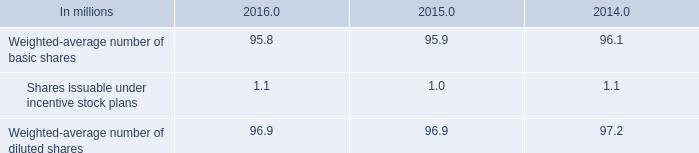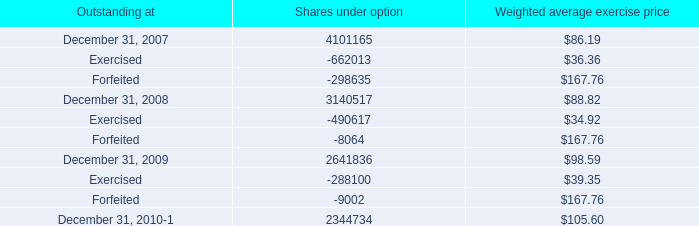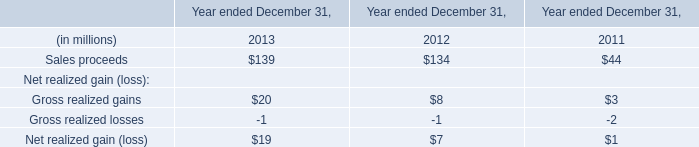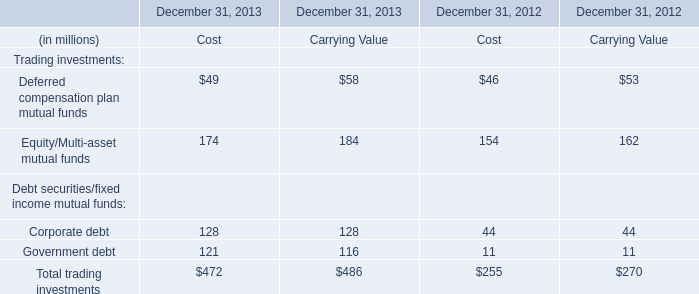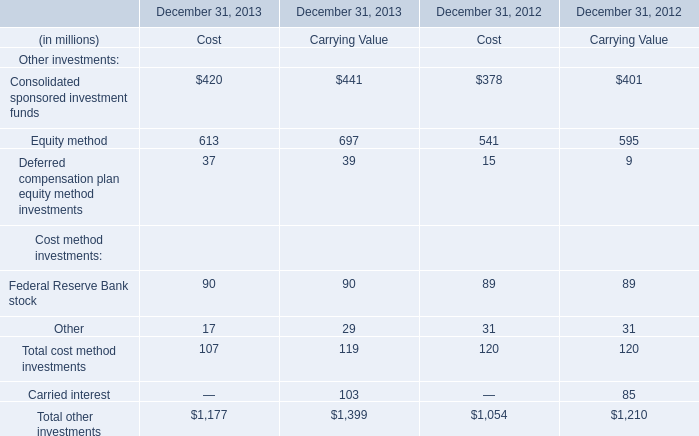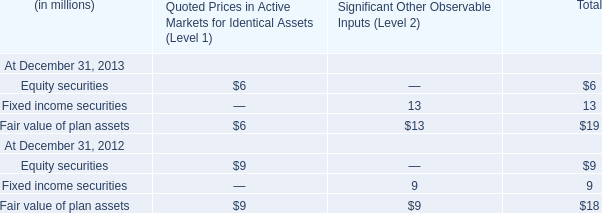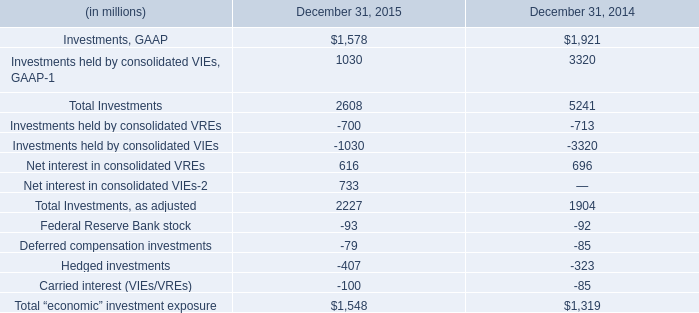In the year with lowest amount of Sales proceeds, what's the amount of Sales proceeds and Gross realized gains? (in million) 
Computations: (44 + 3)
Answer: 47.0. 